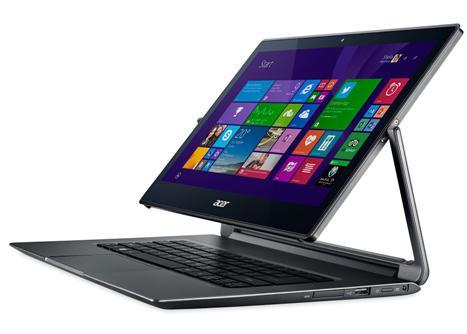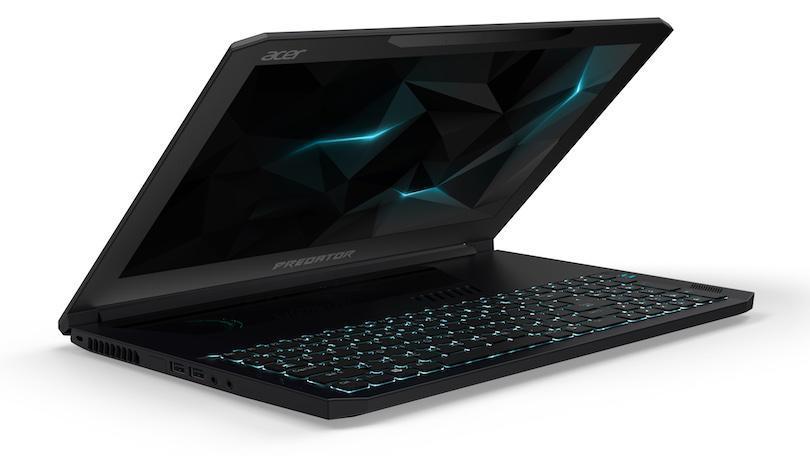The first image is the image on the left, the second image is the image on the right. Examine the images to the left and right. Is the description "The laptop on the right displays the tiles from the operating system Windows." accurate? Answer yes or no. No. 